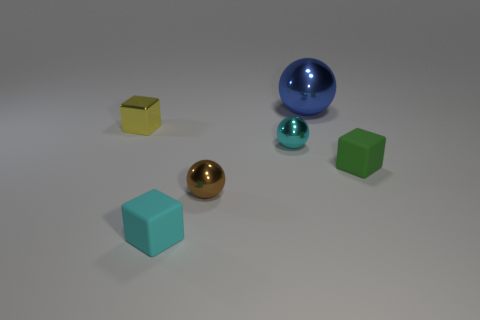Is there any other thing that is the same size as the blue ball?
Your answer should be very brief. No. Is there anything else that is the same shape as the green object?
Offer a very short reply. Yes. What color is the other big thing that is the same shape as the brown shiny thing?
Make the answer very short. Blue. There is a metal ball that is behind the yellow metal cube; is its size the same as the small green rubber block?
Provide a succinct answer. No. There is a ball that is in front of the tiny rubber thing that is to the right of the small brown metal thing; how big is it?
Provide a short and direct response. Small. Does the green thing have the same material as the tiny block that is in front of the green rubber block?
Your answer should be very brief. Yes. Are there fewer yellow metal objects behind the blue metal thing than small cyan metallic things left of the cyan rubber object?
Offer a terse response. No. The other small thing that is made of the same material as the tiny green object is what color?
Give a very brief answer. Cyan. Is there a small green rubber block that is in front of the block on the right side of the big blue metal ball?
Provide a short and direct response. No. There is a matte object that is the same size as the green cube; what color is it?
Give a very brief answer. Cyan. 